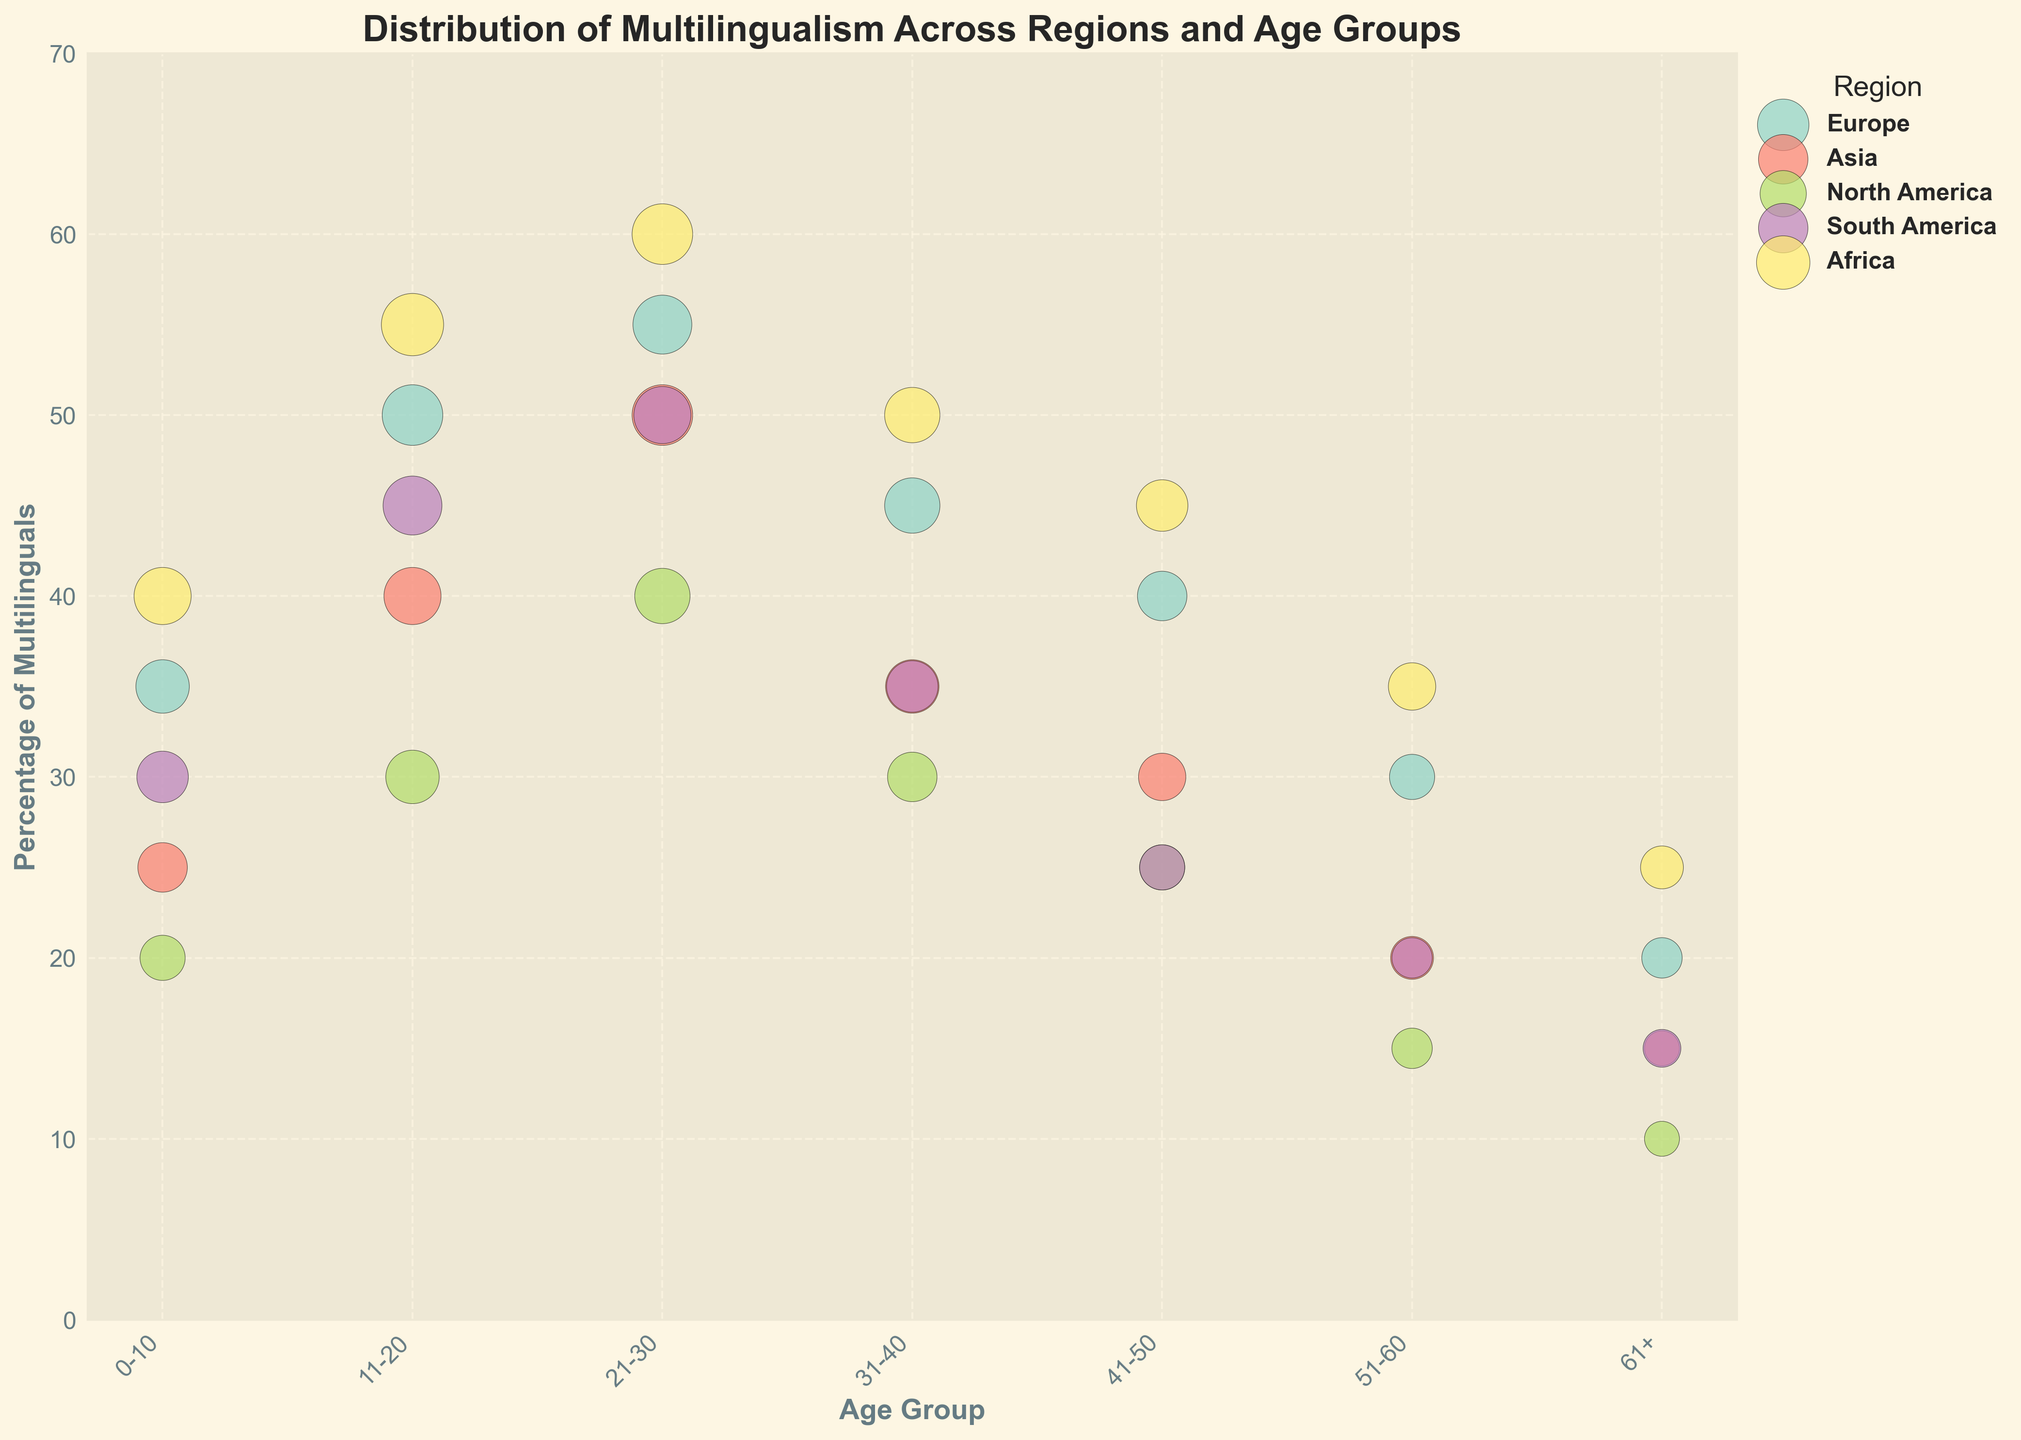Which region has the highest percentage of multilingual individuals in the 21-30 age group? To determine the region with the highest percentage among multilinguals in the 21-30 age group, we observe the points corresponding to this age group across different regions. Africa shows the highest value at 60%.
Answer: Africa What is the title of the subplot? To find the title, refer to the top part of the subplot where the title is usually located. The title of this subplot is clearly visible and reads "Distribution of Multilingualism Across Regions and Age Groups".
Answer: Distribution of Multilingualism Across Regions and Age Groups In which region and age group is the smallest bubble, and what does it represent? To identify the smallest bubble, examine the plot for points with the smallest size. North America for the 61+ age group has the smallest bubble size. This bubble represents a 10% multilingual population with a size of 30.
Answer: North America, 61+ Compare the percentage of multilingualism between Europe and South America for the age group 11-20. Which has a higher percentage, and by how much? Looking at the age group 11-20, Europe has 50% and South America has 45%. Therefore, Europe has a higher percentage by 5%.
Answer: Europe, by 5% Which age group in Asia has the highest percentage of multilinguals, and what is this percentage? For the highest percentage in Asia, scan the percentages for each age group. The highest value for Asia is in the 21-30 age group, at 50%.
Answer: 21-30, 50% What are the axis labels of the bubble chart? The labels for the axes are found adjacent to the axes. The x-axis label is 'Age Group' and the y-axis label is 'Percentage of Multilinguals'.
Answer: Age Group and Percentage of Multilinguals What can be inferred about the trend of multilingualism in Africa across age groups? Observing the trend for Africa, the percentage of multilinguals decreases from 0-10 (40%) to 61+ (25%) but has the highest value in the 21-30 age group (60%). This suggests a peak at the younger adult age and gradually decreases with age.
Answer: Decreases with age, peaks at 21-30 Which two regions have the closest percentages of multilinguals in the 31-40 age group and what are these percentages? Looking at the values for the 31-40 age group, Europe has 45% and Asia has 35%. The two regions with the closest values are South America (35%) and Asia (35%).
Answer: South America and Asia, both at 35% What color indicators are used to identify the different regions in the plot? This can be determined by referring to the legend on the plot. Each region has a distinctive color assigned to it for easy identification. A detailed list isn't shown in the figure data, but they are represented by unique shades from the 'Set3' colormap.
Answer: Unique shades for each region 